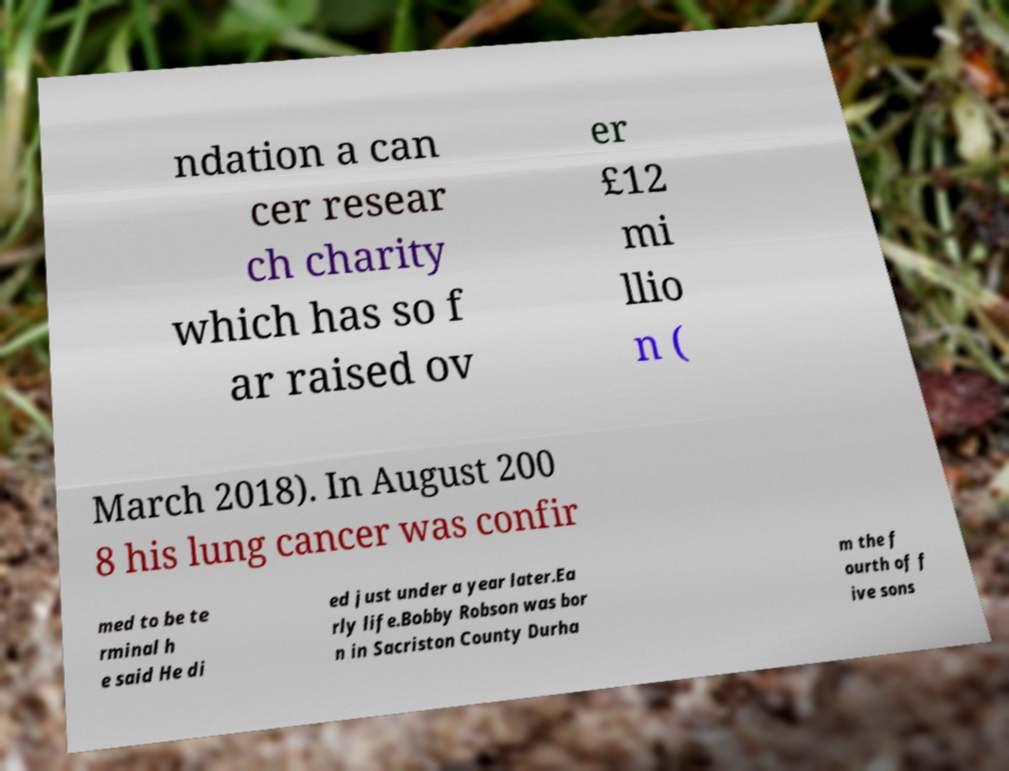There's text embedded in this image that I need extracted. Can you transcribe it verbatim? ndation a can cer resear ch charity which has so f ar raised ov er £12 mi llio n ( March 2018). In August 200 8 his lung cancer was confir med to be te rminal h e said He di ed just under a year later.Ea rly life.Bobby Robson was bor n in Sacriston County Durha m the f ourth of f ive sons 